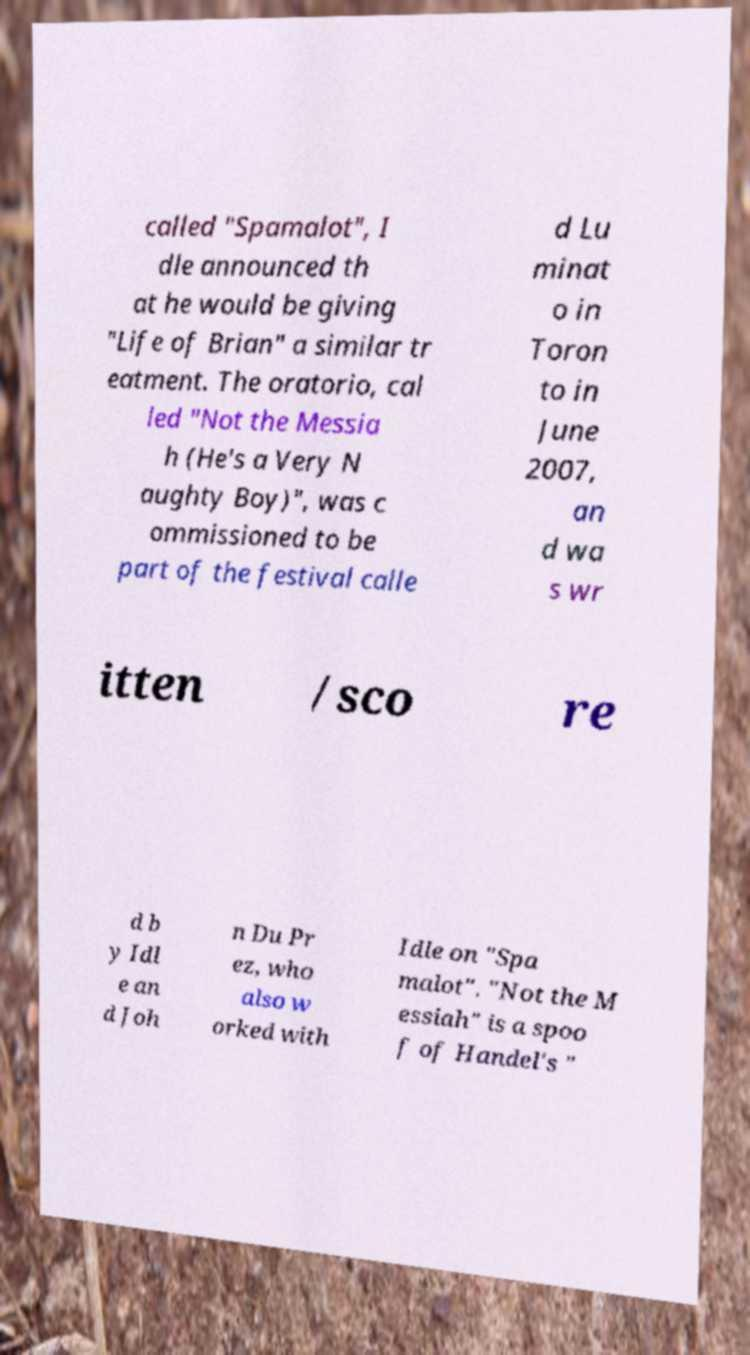What messages or text are displayed in this image? I need them in a readable, typed format. called "Spamalot", I dle announced th at he would be giving "Life of Brian" a similar tr eatment. The oratorio, cal led "Not the Messia h (He's a Very N aughty Boy)", was c ommissioned to be part of the festival calle d Lu minat o in Toron to in June 2007, an d wa s wr itten /sco re d b y Idl e an d Joh n Du Pr ez, who also w orked with Idle on "Spa malot". "Not the M essiah" is a spoo f of Handel's " 